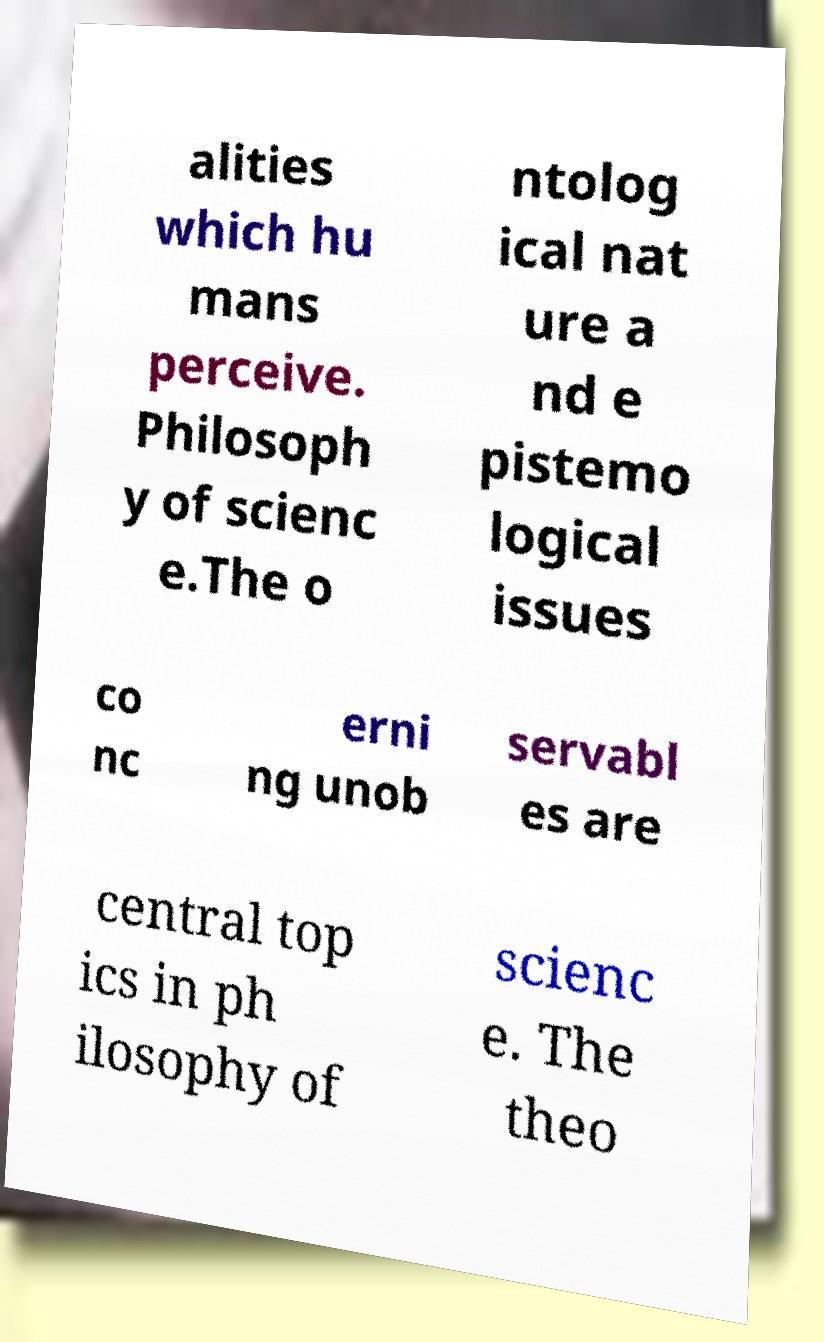Please read and relay the text visible in this image. What does it say? alities which hu mans perceive. Philosoph y of scienc e.The o ntolog ical nat ure a nd e pistemo logical issues co nc erni ng unob servabl es are central top ics in ph ilosophy of scienc e. The theo 